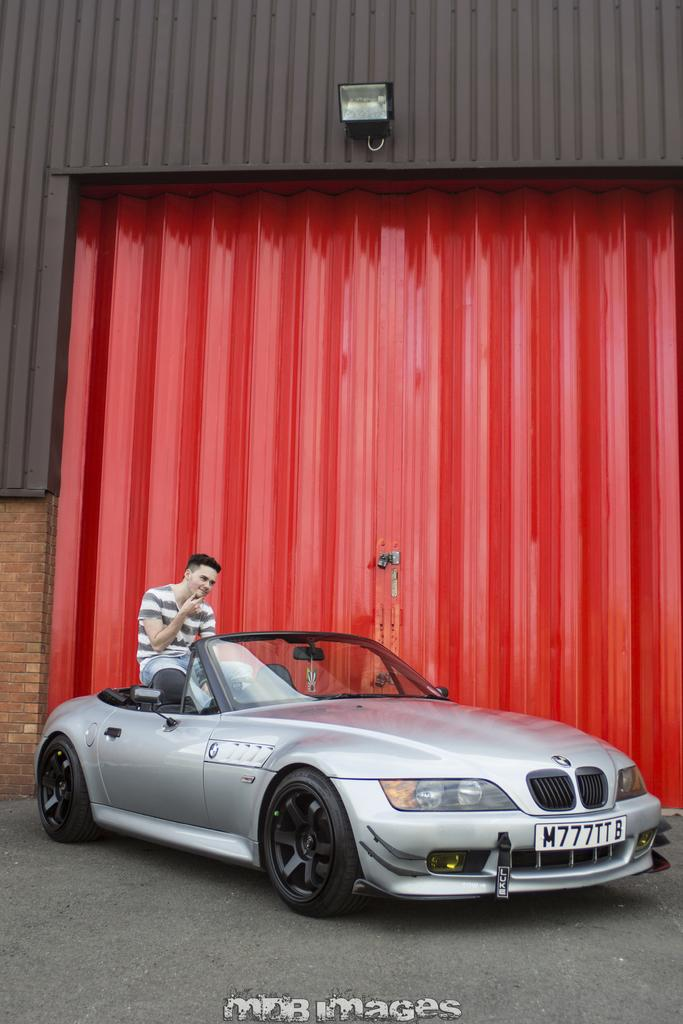What is the main subject of the image? There is a car in the image. What is the person in the image doing? A person is sitting on the car. What can be seen behind the car? There is a red-colored shed behind the car. What is on top of the shed? There is a light on top of the shed. Can you see a mountain in the background of the image? No, there is no mountain visible in the image. What type of knife is the person using to cut the car? There is no knife present in the image, and the person is not cutting the car. 